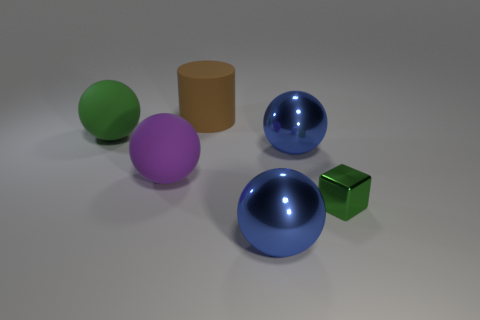Subtract all purple spheres. How many spheres are left? 3 Subtract all blue spheres. How many spheres are left? 2 Add 4 small blue rubber spheres. How many objects exist? 10 Subtract 0 red blocks. How many objects are left? 6 Subtract all cubes. How many objects are left? 5 Subtract all brown blocks. Subtract all red balls. How many blocks are left? 1 Subtract all gray spheres. How many brown cubes are left? 0 Subtract all big blue things. Subtract all large metal spheres. How many objects are left? 2 Add 1 green cubes. How many green cubes are left? 2 Add 4 large purple objects. How many large purple objects exist? 5 